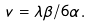<formula> <loc_0><loc_0><loc_500><loc_500>v = \lambda \beta / 6 \alpha .</formula> 